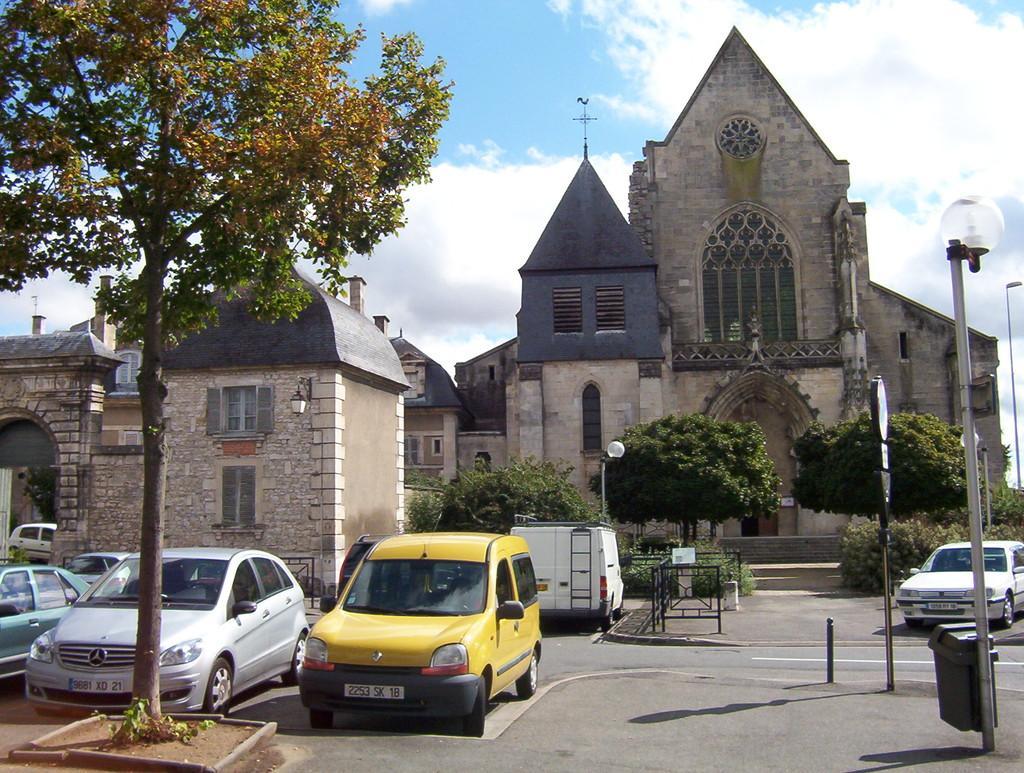Could you give a brief overview of what you see in this image? In this image there are vehicles on the road. In the front on the left side there is a tree. In the background there are buildings, trees, poles, and the sky is cloudy. 